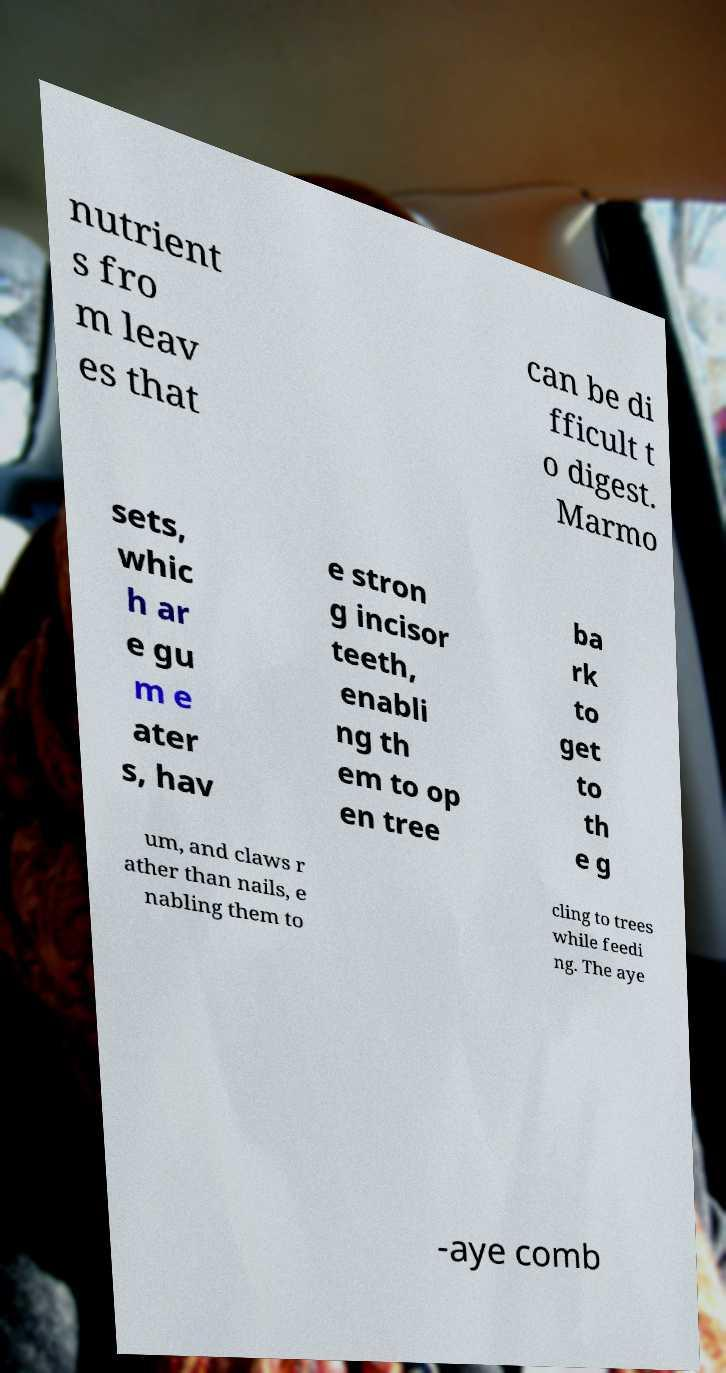Please identify and transcribe the text found in this image. nutrient s fro m leav es that can be di fficult t o digest. Marmo sets, whic h ar e gu m e ater s, hav e stron g incisor teeth, enabli ng th em to op en tree ba rk to get to th e g um, and claws r ather than nails, e nabling them to cling to trees while feedi ng. The aye -aye comb 